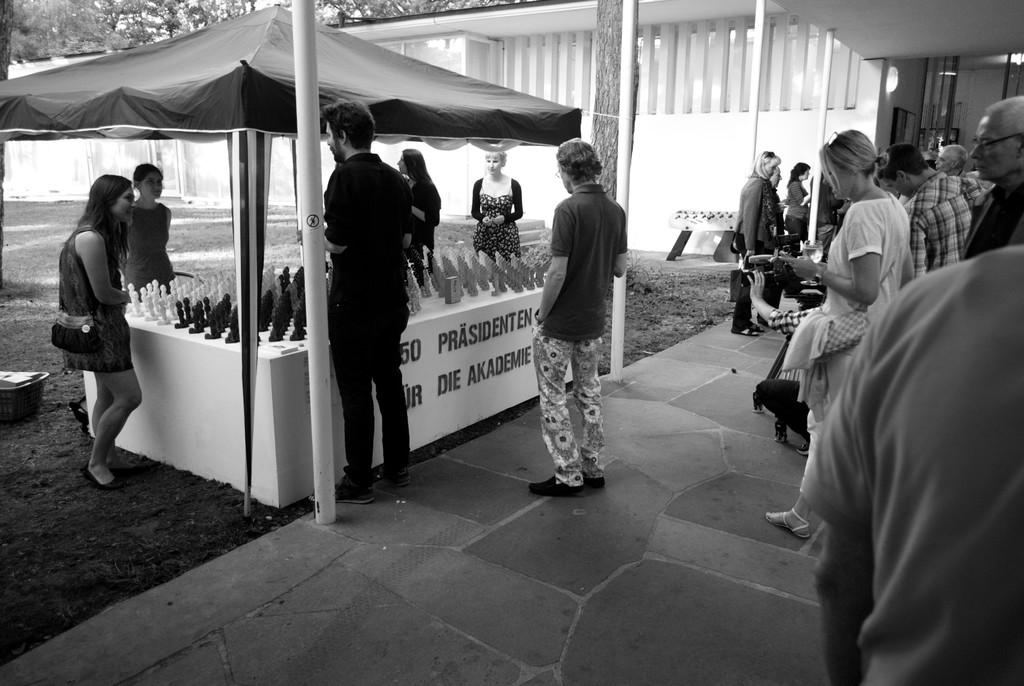What are the people in the image doing? There is a group of people standing on the ground in the image. What else can be seen in the image besides the people? There are toys, poles, a tent, and a building visible in the image. What is in the background of the image? There are trees in the background of the image. What type of cakes are being served at the war in the image? There is no war or cakes present in the image. What is the head of the person doing in the image? There is no specific action being performed by the head of any person in the image, as the image only shows the group of people standing on the ground. 